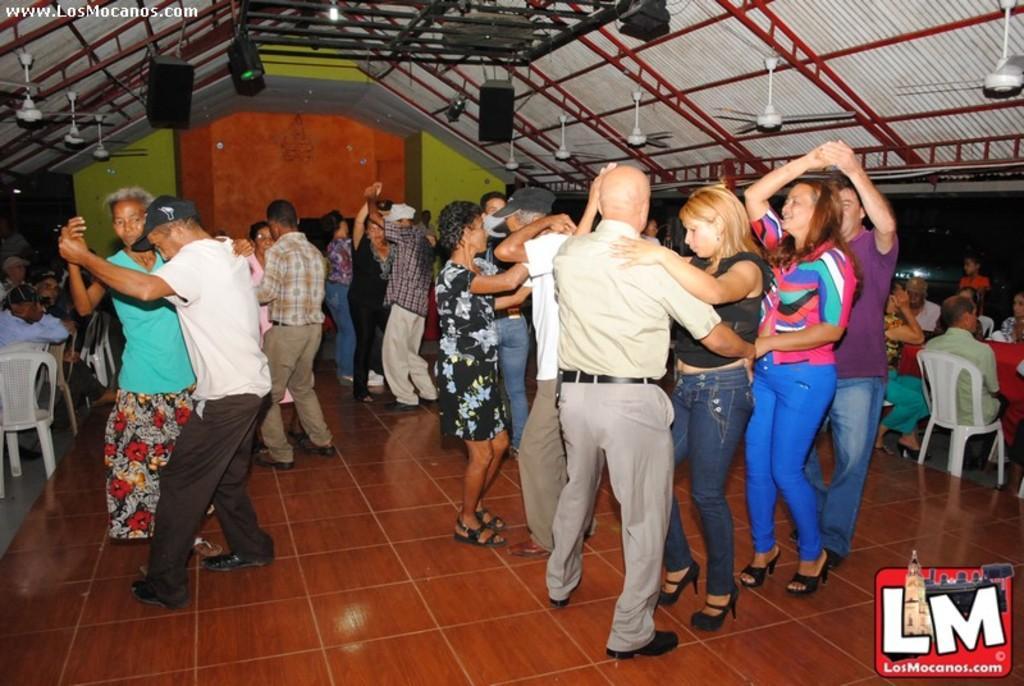Can you describe this image briefly? In this image, we can see a group of people. On the right side and left side of the image, we can see few people are sitting on the chairs. Here we can see a group of people are dancing on the floor. Background there is a wall. Top of the image, we can see speakers, fans, rods and shed. On the right side bottom, there is a logo. 